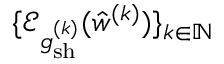<formula> <loc_0><loc_0><loc_500><loc_500>\{ \mathcal { E } _ { \mathfrak { g } _ { s h } ^ { ( k ) } } ( \hat { w } ^ { ( k ) } ) \} _ { k \in \mathbb { N } }</formula> 